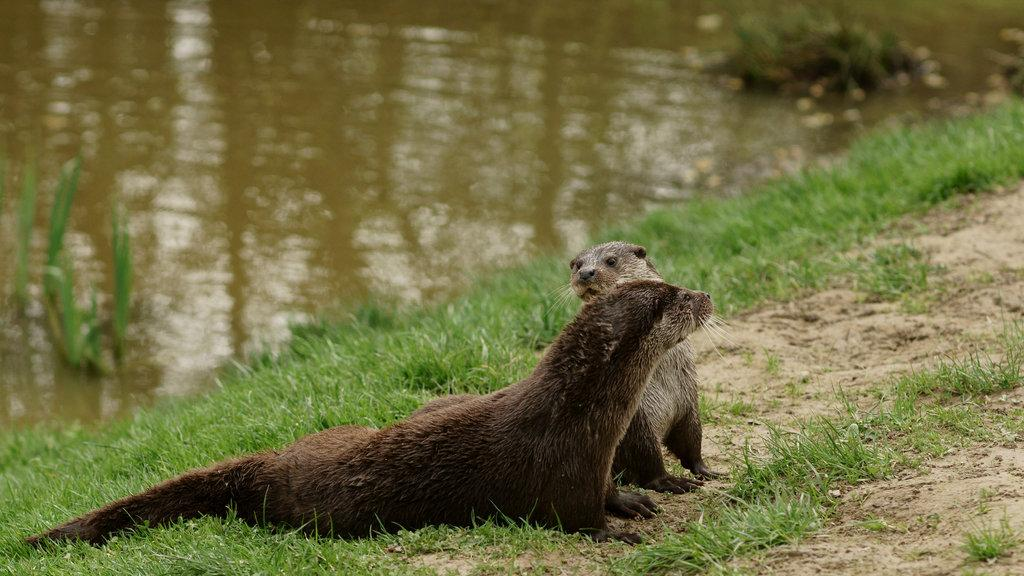What type of animals can be seen in the image? There are animals on the ground in the image. What is the terrain like in the image? There is grass visible in the image. What can be seen in the distance in the image? There is water visible in the background of the image. What is the mass of the spark that caused the animals to attack in the image? There is no spark or attack present in the image; the animals are simply on the ground. 